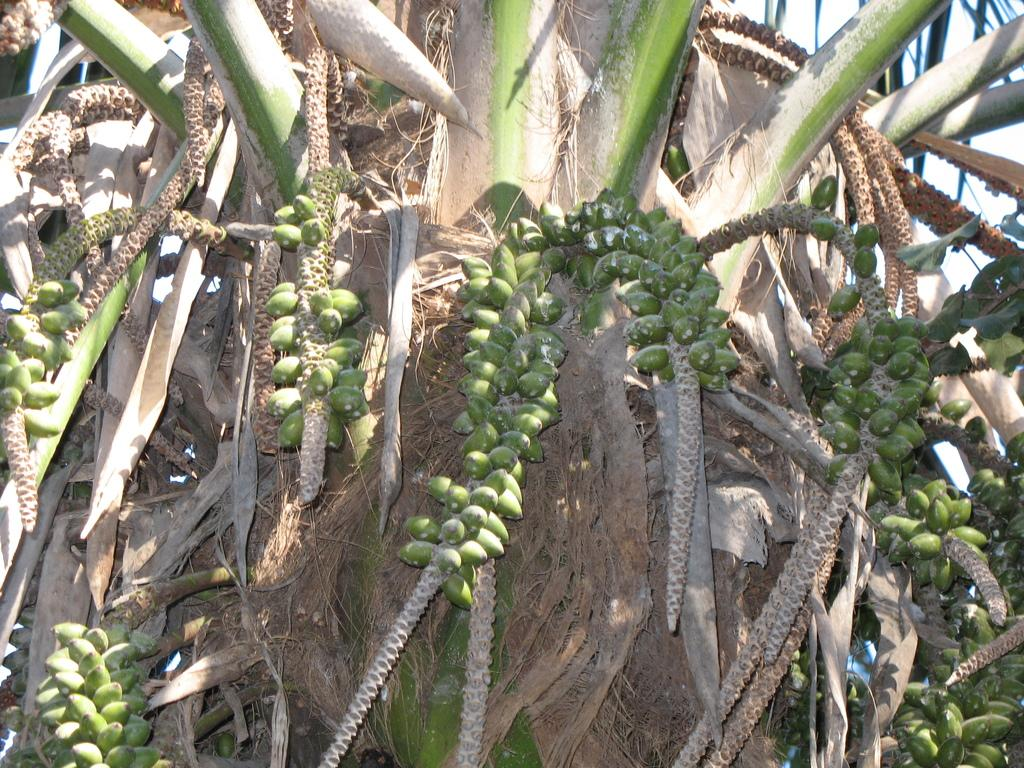What type of vegetation can be seen in the image? There are many fruits on the tree in the image. What can be seen in the background of the image? The sky is visible in the background of the image. How does the rabbit interact with the fruits on the tree in the image? There is no rabbit present in the image; it only features a tree with fruits and the sky in the background. 